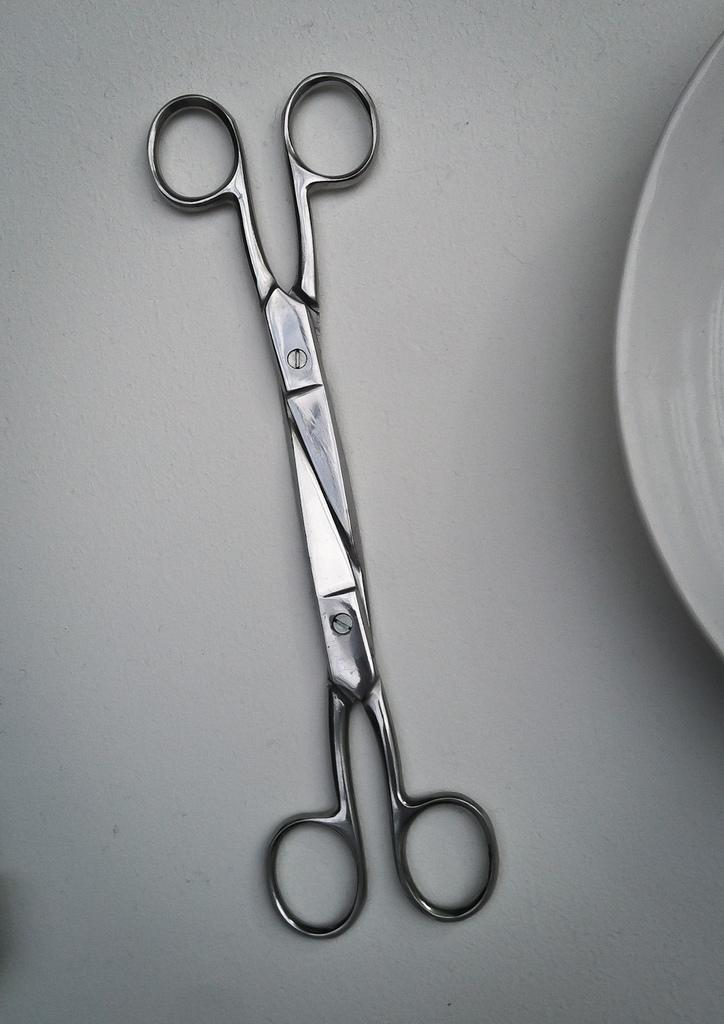What object can be seen on a surface in the image? There are scissors on a surface in the image. What other object is visible on the right side of the image? There is a platter-like object on the right side of the image. How many geese are sitting on the platter-like object in the image? There are no geese present in the image, and the platter-like object does not have any geese on it. 